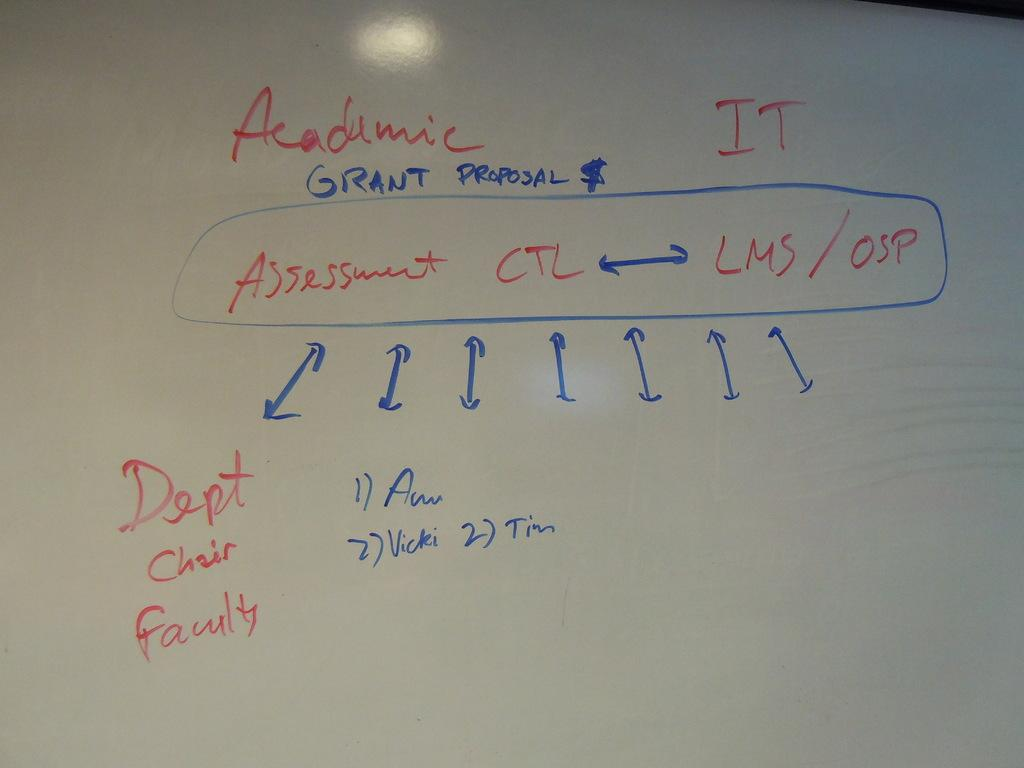<image>
Relay a brief, clear account of the picture shown. A board with writing in red and blue with the words Dept Chair Faulty toward the bottom of the board. 